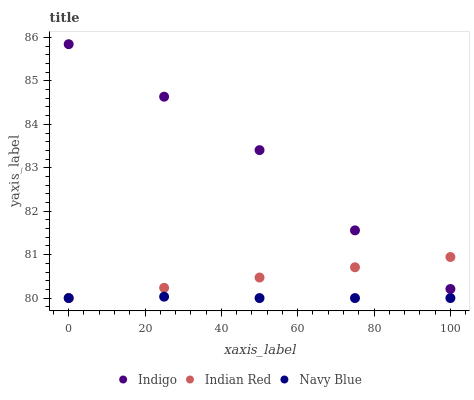Does Navy Blue have the minimum area under the curve?
Answer yes or no. Yes. Does Indigo have the maximum area under the curve?
Answer yes or no. Yes. Does Indian Red have the minimum area under the curve?
Answer yes or no. No. Does Indian Red have the maximum area under the curve?
Answer yes or no. No. Is Indian Red the smoothest?
Answer yes or no. Yes. Is Indigo the roughest?
Answer yes or no. Yes. Is Indigo the smoothest?
Answer yes or no. No. Is Indian Red the roughest?
Answer yes or no. No. Does Navy Blue have the lowest value?
Answer yes or no. Yes. Does Indigo have the lowest value?
Answer yes or no. No. Does Indigo have the highest value?
Answer yes or no. Yes. Does Indian Red have the highest value?
Answer yes or no. No. Is Navy Blue less than Indigo?
Answer yes or no. Yes. Is Indigo greater than Navy Blue?
Answer yes or no. Yes. Does Navy Blue intersect Indian Red?
Answer yes or no. Yes. Is Navy Blue less than Indian Red?
Answer yes or no. No. Is Navy Blue greater than Indian Red?
Answer yes or no. No. Does Navy Blue intersect Indigo?
Answer yes or no. No. 